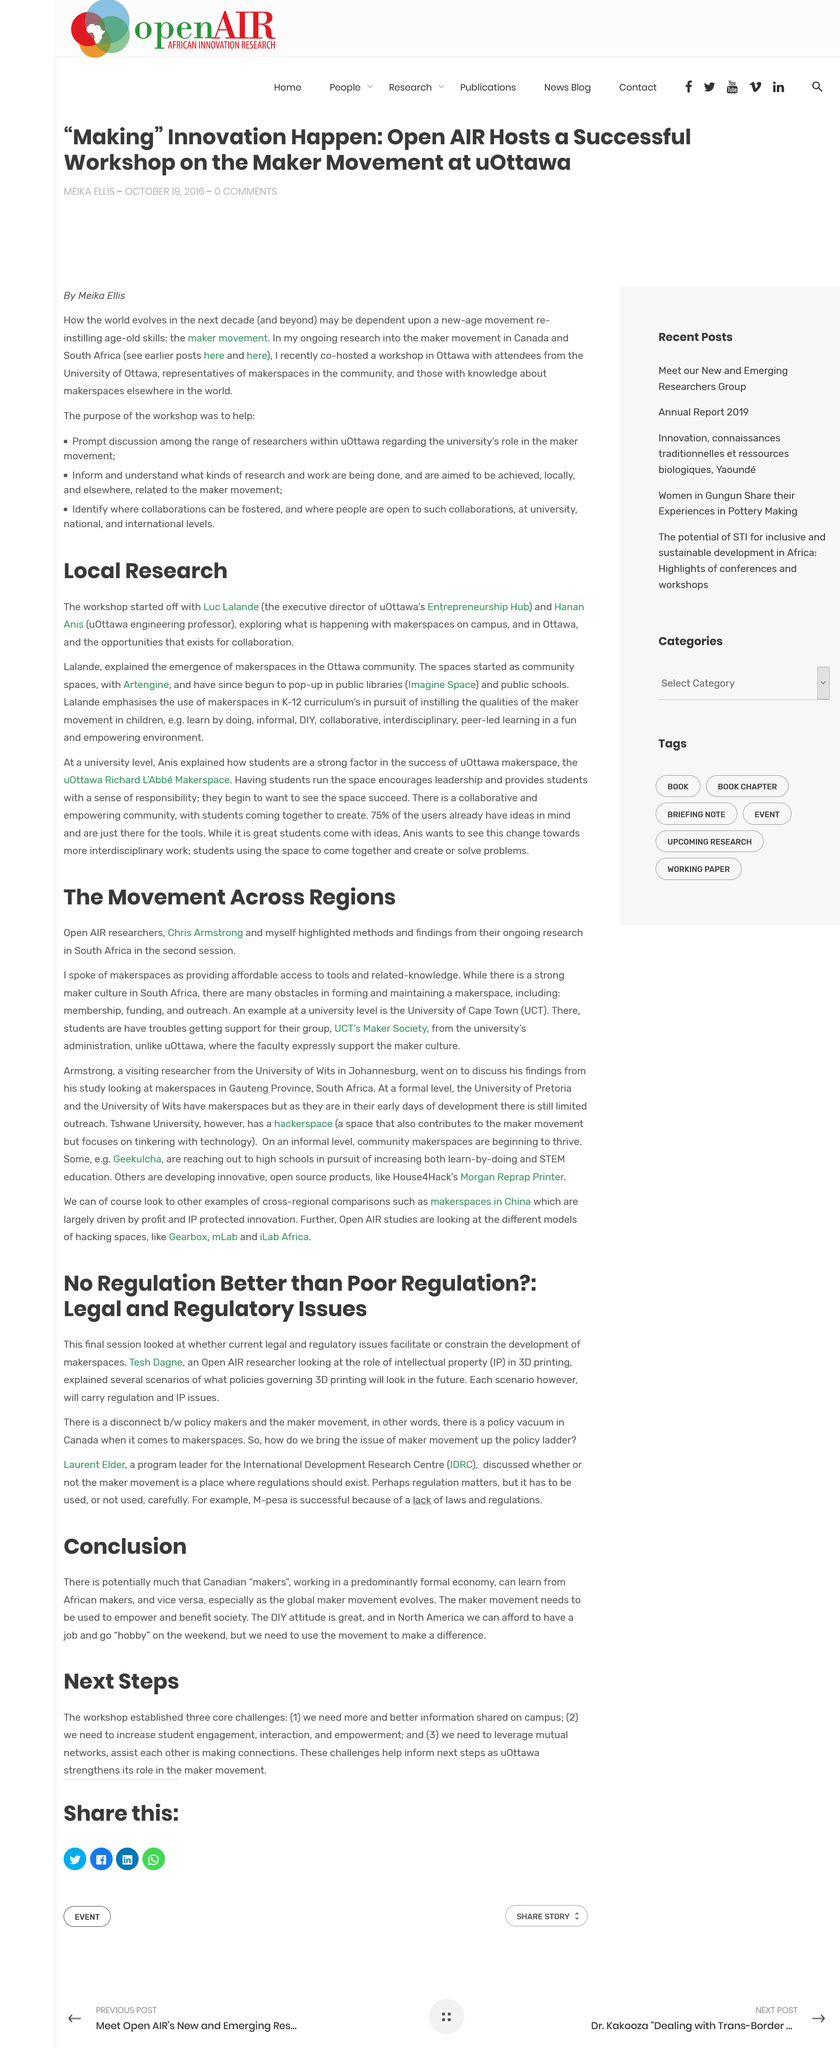Identify some key points in this picture. Luc Lalande is the executive director of the University of Ottawa's Entrepreneurship Hub. The methods and findings were delivered in the second session. Luc Lalande and Hanan Anis started off in the workshop. The sharing of more and better information on campus presents a challenge to the workshop. There is a significant disconnect between policy makers and the maker movement. 